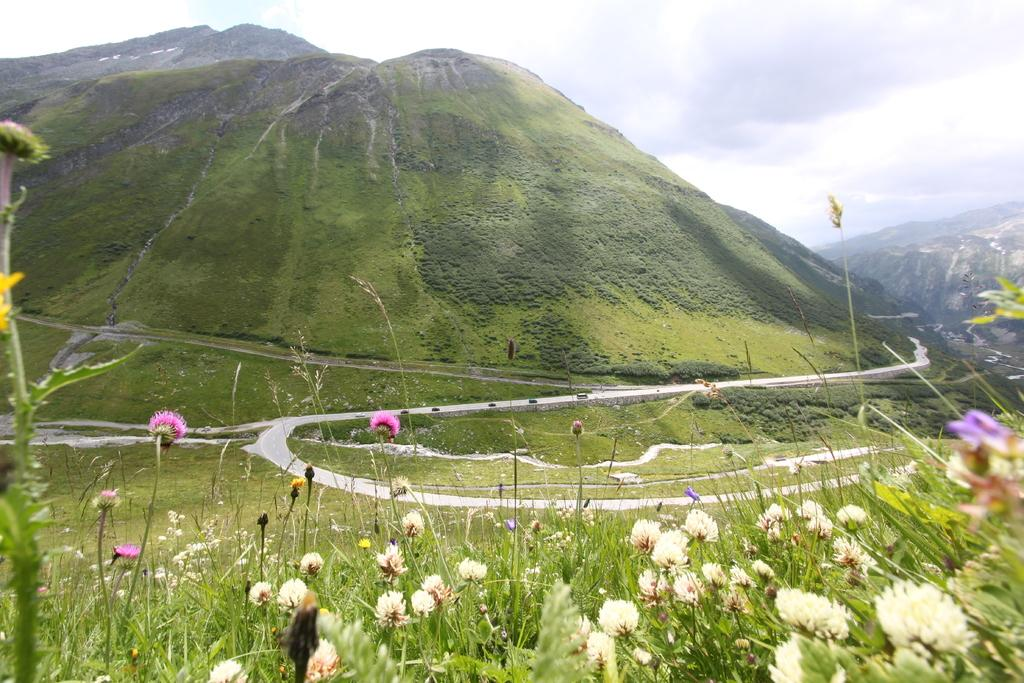What type of vegetation is present in the image? There are many flowers and plants in the image. What can be seen in the background of the image? There are mountains, roads, and the sky visible in the background of the image. What type of alley can be seen in the image? There is no alley present in the image. What emotion is depicted by the flowers in the image? The flowers in the image do not depict any specific emotion; they are simply plants. 